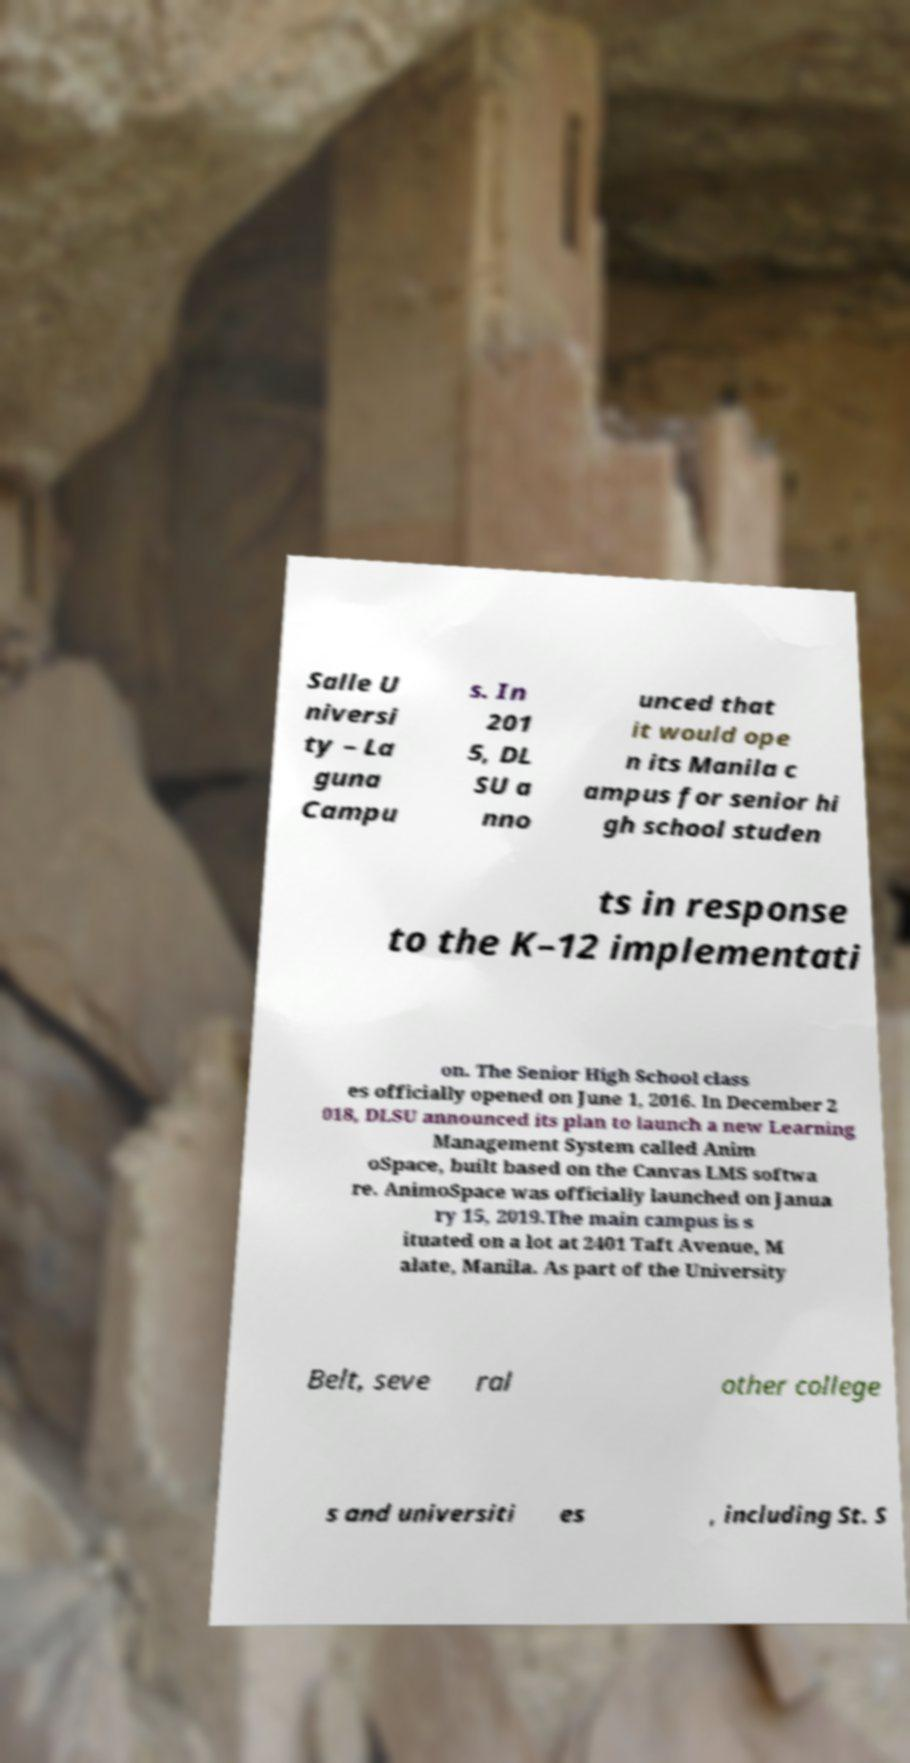Could you extract and type out the text from this image? Salle U niversi ty – La guna Campu s. In 201 5, DL SU a nno unced that it would ope n its Manila c ampus for senior hi gh school studen ts in response to the K–12 implementati on. The Senior High School class es officially opened on June 1, 2016. In December 2 018, DLSU announced its plan to launch a new Learning Management System called Anim oSpace, built based on the Canvas LMS softwa re. AnimoSpace was officially launched on Janua ry 15, 2019.The main campus is s ituated on a lot at 2401 Taft Avenue, M alate, Manila. As part of the University Belt, seve ral other college s and universiti es , including St. S 